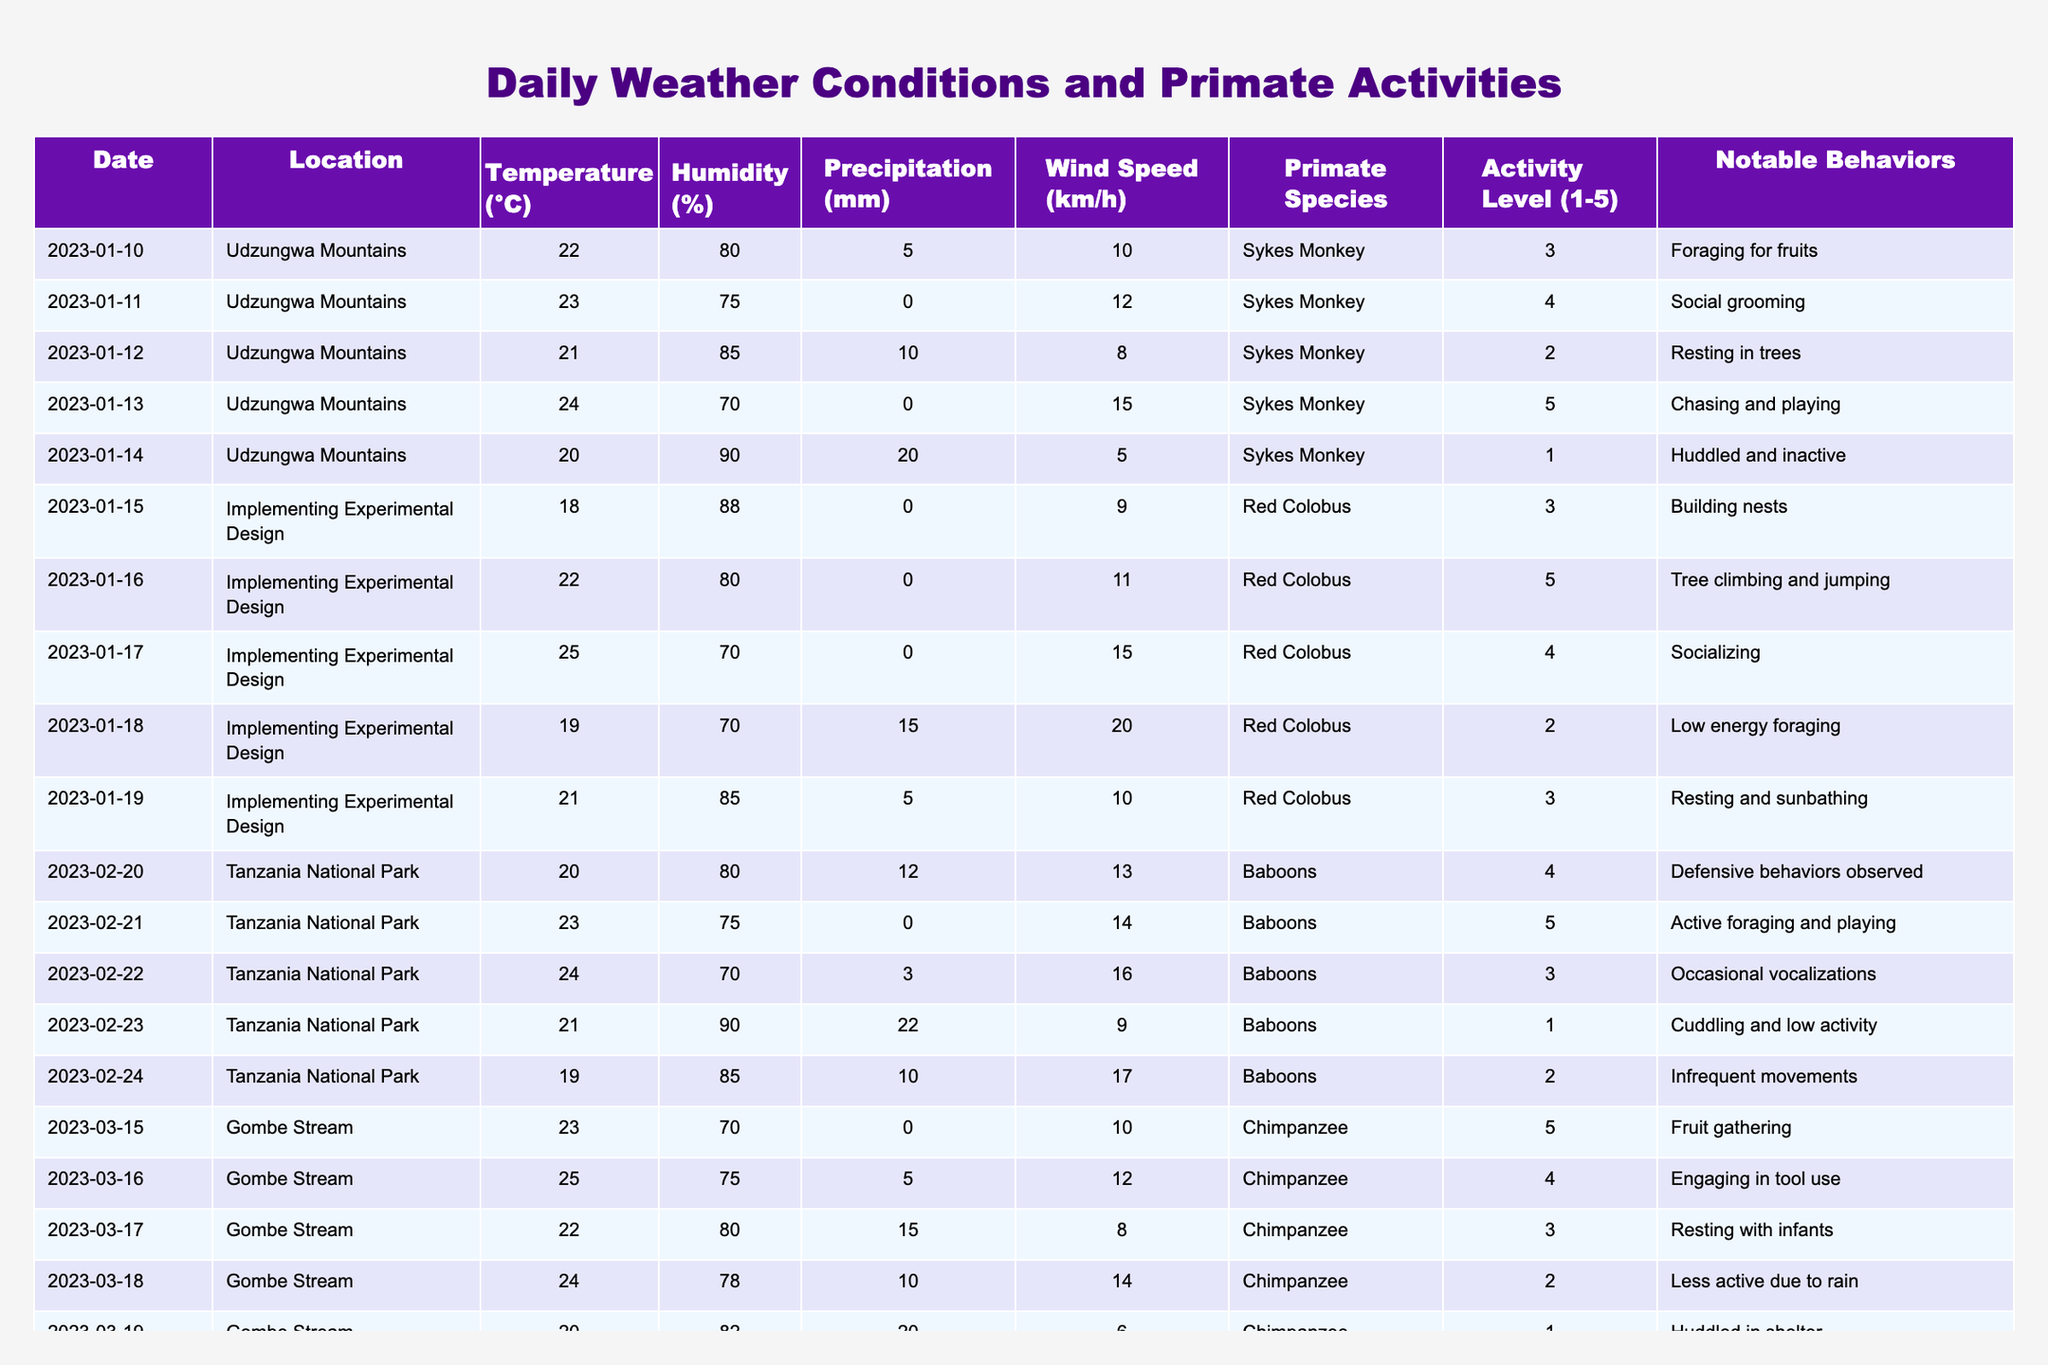What was the temperature on January 12, 2023? Referring to the table, the entry for January 12, 2023, indicates that the temperature was 21°C.
Answer: 21°C Which primate species was most active on January 13, 2023? The table shows that on January 13, 2023, the Sykes Monkey had an activity level of 5, which indicates high activity.
Answer: Sykes Monkey What is the average humidity percentage for the Red Colobus across all recorded days? The humidity percentages for the Red Colobus are 88, 80, 70, 70, and 85. The sum is 393, and there are 5 entries, so the average is 393/5 = 78.6%.
Answer: 78.6% Did Baboon activity levels vary significantly with changes in precipitation? By examining the table, when there was 22mm precipitation, the Baboon's activity was rated at 1. When there was no precipitation, the activity was rated at 5. This suggests significant variation based on precipitation levels.
Answer: Yes What notable behavior did Chimpanzees demonstrate when the temperature was highest? The highest temperature recorded for Chimpanzees was 25°C on March 16, and they engaged in tool use, indicating notable behavior during higher temperatures.
Answer: Engaging in tool use Was the highest recorded wind speed correlated to low activity levels for any primate species? Looking at the table, the highest wind speed recorded was 20 km/h on January 18, 2023, with Red Colobus showing an activity level of 2, indicating low activity. This shows a correlation between high wind and low activity.
Answer: Yes Which primate species showed a notable behavioral change due to rain, and what was the change? Observing the table, Chimpanzees had their activity drop on March 18, 2023, with rain reported at 10mm and an activity level of 2 (less active).
Answer: Chimpanzees; less active What was the trend in activity levels for Golden Monkeys as temperature increased from 18°C to 21°C? The activity levels for Golden Monkeys were 5 (at 18°C), 4 (at 19°C), and 3 (at 20°C). This shows a declining trend in activity as the temperature increased.
Answer: Declining trend On which date did Red Colobus have low energy foraging activity, and what were the temperature and humidity on that date? Red Colobus had low energy foraging activity on January 18, 2023, with a temperature of 19°C and humidity at 70%.
Answer: January 18, 2023; 19°C, 70% Was there any day with high temperatures where no primate species engaged in high activity? The highest temperature of 25°C was recorded on January 17, 2023, for Red Colobus with an activity level of 4, indicating that there was no day with high temperatures and low activity.
Answer: No 